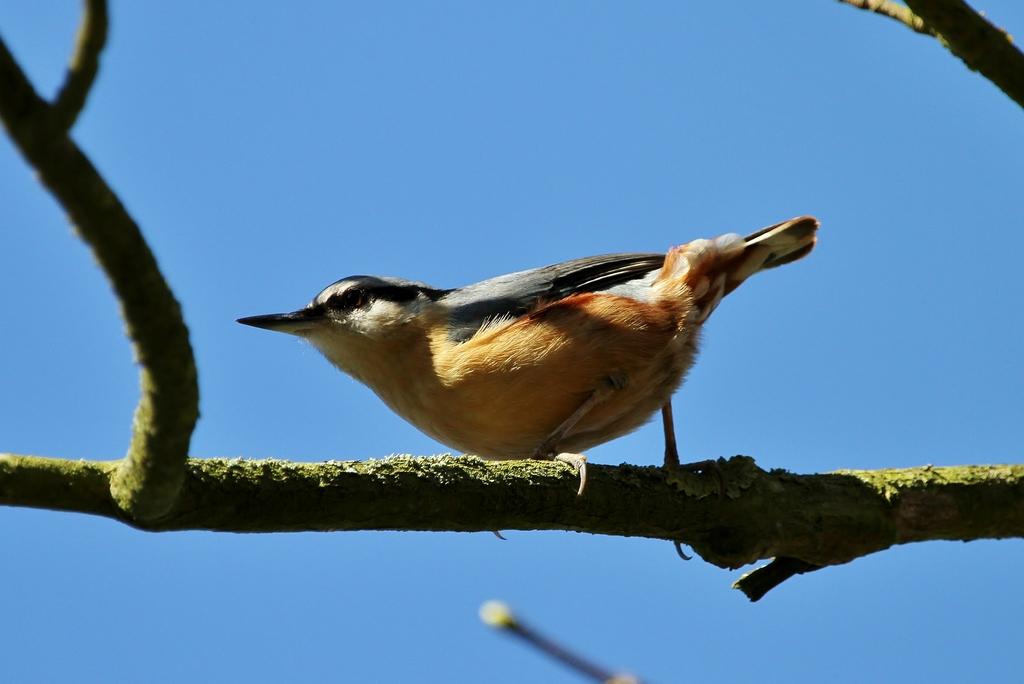What is the main subject in the center of the image? There is a bird on a tree in the center of the image. What can be seen in the background of the image? The sky is visible in the background of the image. Are there any fairies flying around the bird in the image? There are no fairies present in the image; it only features a bird on a tree and the sky in the background. 